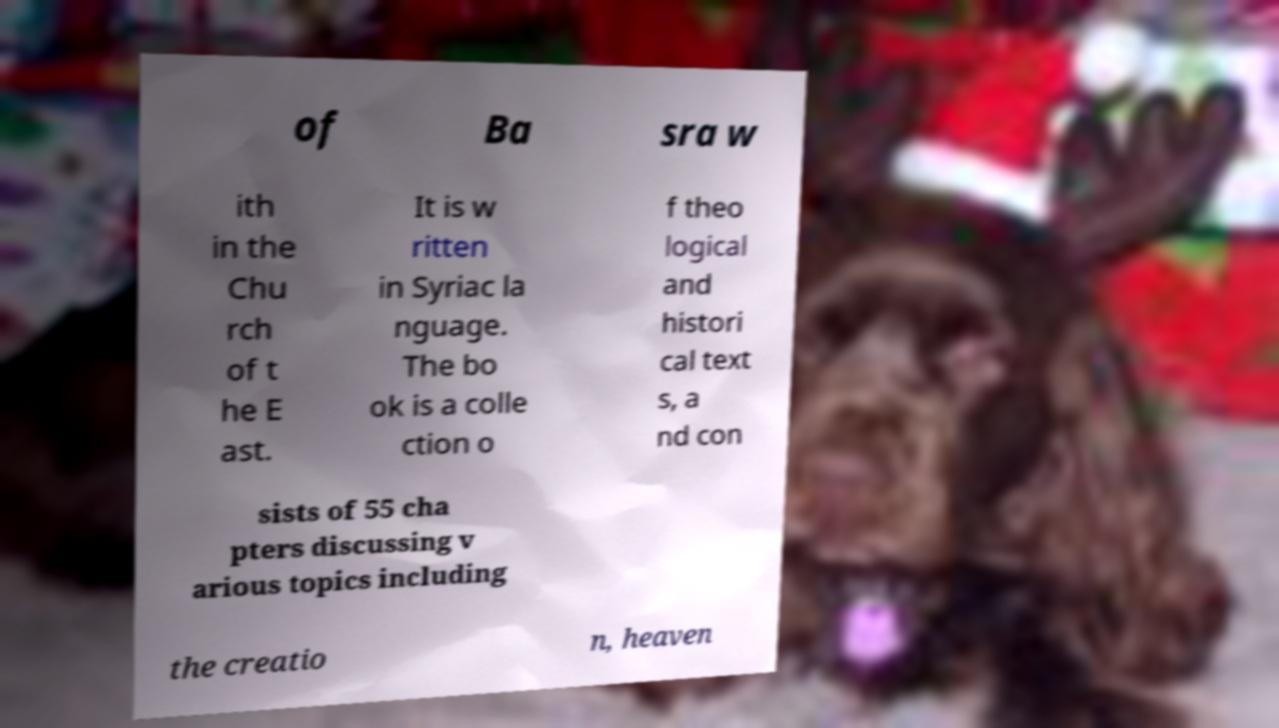There's text embedded in this image that I need extracted. Can you transcribe it verbatim? of Ba sra w ith in the Chu rch of t he E ast. It is w ritten in Syriac la nguage. The bo ok is a colle ction o f theo logical and histori cal text s, a nd con sists of 55 cha pters discussing v arious topics including the creatio n, heaven 